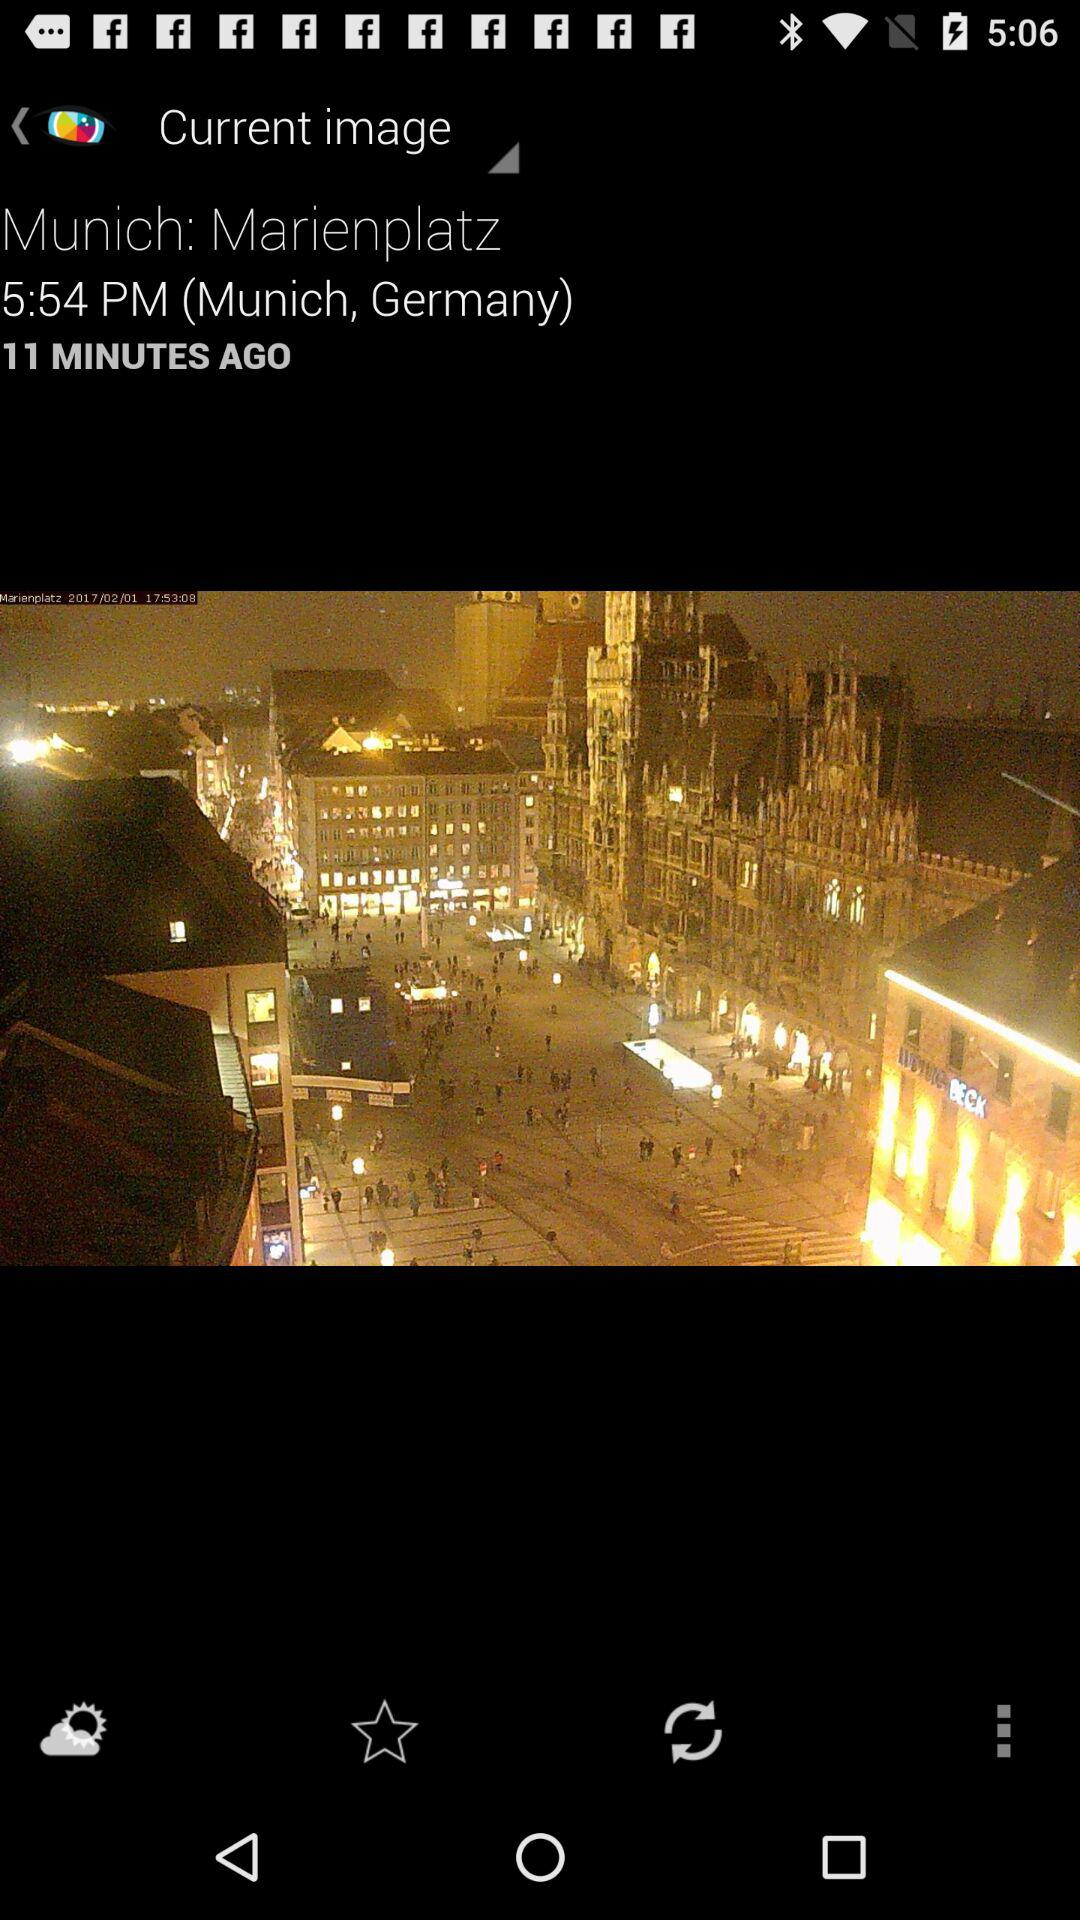When was the image posted? The image was posted 11 minutes ago. 